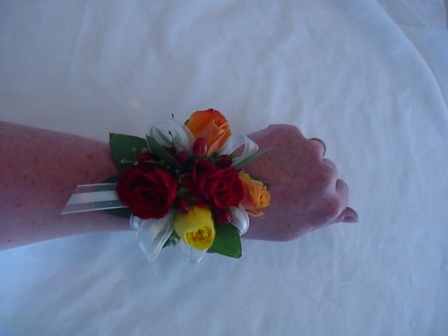Think of a whimsical and imaginative context for this image. In an enchanted forest where flowers could talk and rainbows bloomed between the trees, there lived a fairy named Lila. In this magical place, special events were marked by the gifting of enchanted corsages. One day, as the Forest Festival approached, Lila created the most vibrant corsage she had ever made, with roses that shimmered in red, yellow, and orange, each petal whispering a spell of joy and celebration. The ribbons she chose were woven from the silk spun by moonlit spiders, adding a touch of ethereal beauty. Lila carefully placed the corsage on a white satin cushion, knowing that this special piece would find its way to the one forest creature whose heart was pure and kind, bringing them an unforgettable adventure under the twinkling stars of the enchanted canopy. And as the night of the Festival drew closer, the corsage began to glow softly, ready to bestow its magic on its deserving wearer. 